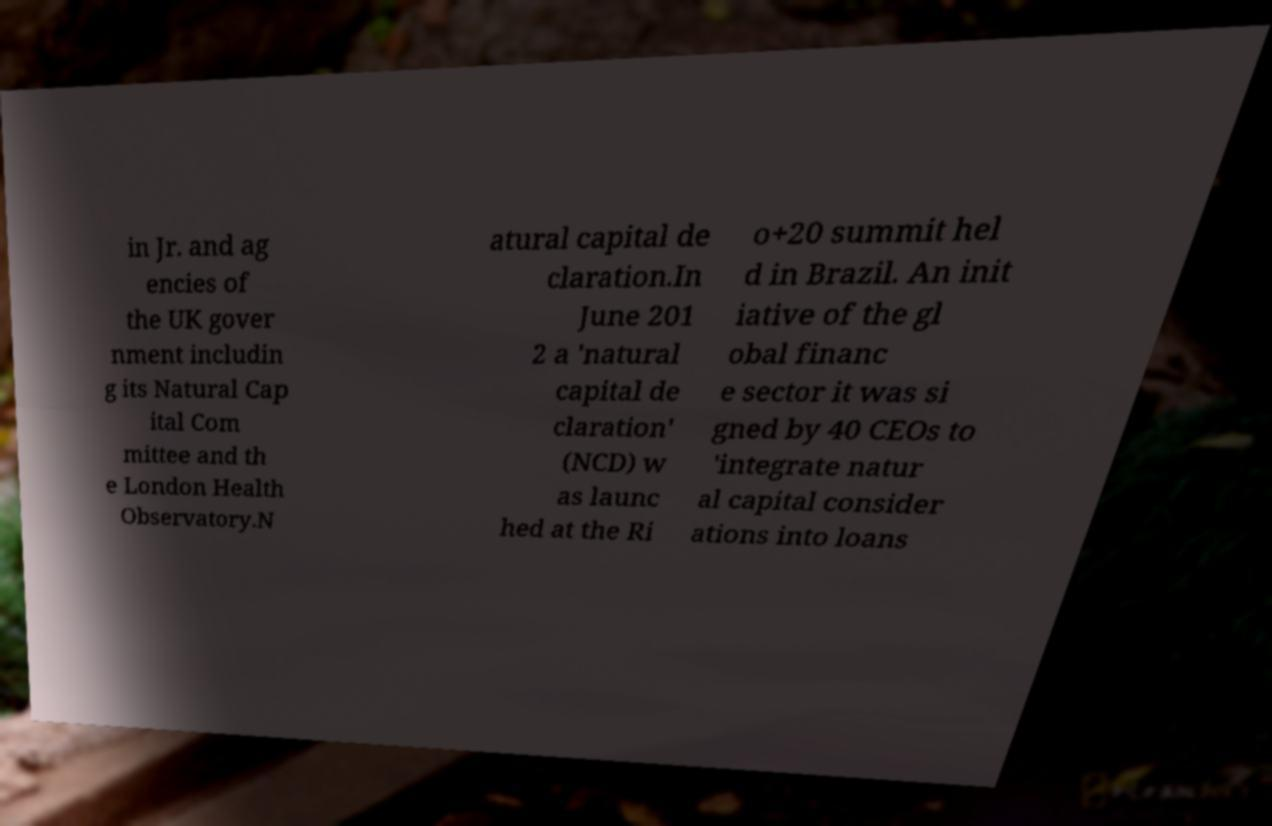Could you extract and type out the text from this image? in Jr. and ag encies of the UK gover nment includin g its Natural Cap ital Com mittee and th e London Health Observatory.N atural capital de claration.In June 201 2 a 'natural capital de claration' (NCD) w as launc hed at the Ri o+20 summit hel d in Brazil. An init iative of the gl obal financ e sector it was si gned by 40 CEOs to 'integrate natur al capital consider ations into loans 